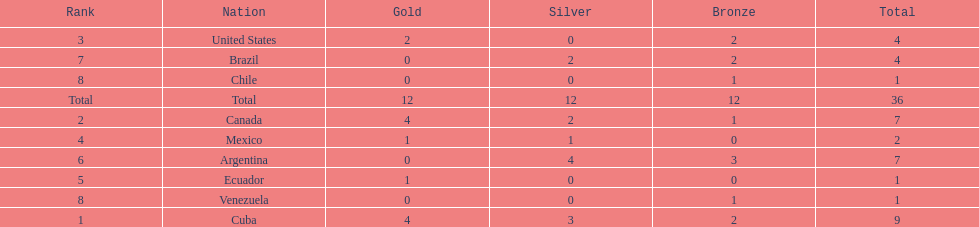Give me the full table as a dictionary. {'header': ['Rank', 'Nation', 'Gold', 'Silver', 'Bronze', 'Total'], 'rows': [['3', 'United States', '2', '0', '2', '4'], ['7', 'Brazil', '0', '2', '2', '4'], ['8', 'Chile', '0', '0', '1', '1'], ['Total', 'Total', '12', '12', '12', '36'], ['2', 'Canada', '4', '2', '1', '7'], ['4', 'Mexico', '1', '1', '0', '2'], ['6', 'Argentina', '0', '4', '3', '7'], ['5', 'Ecuador', '1', '0', '0', '1'], ['8', 'Venezuela', '0', '0', '1', '1'], ['1', 'Cuba', '4', '3', '2', '9']]} How many total medals were there all together? 36. 